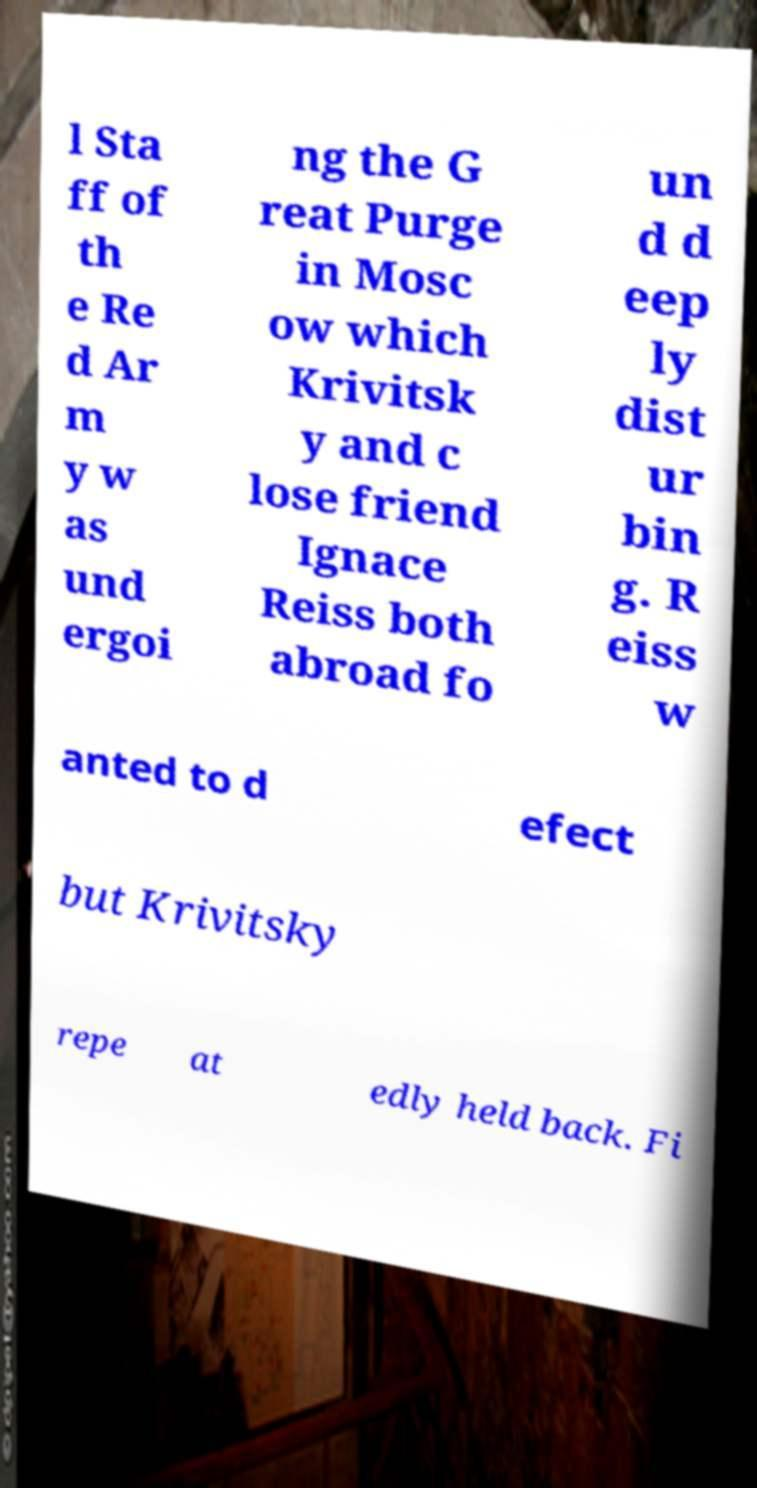Could you assist in decoding the text presented in this image and type it out clearly? l Sta ff of th e Re d Ar m y w as und ergoi ng the G reat Purge in Mosc ow which Krivitsk y and c lose friend Ignace Reiss both abroad fo un d d eep ly dist ur bin g. R eiss w anted to d efect but Krivitsky repe at edly held back. Fi 